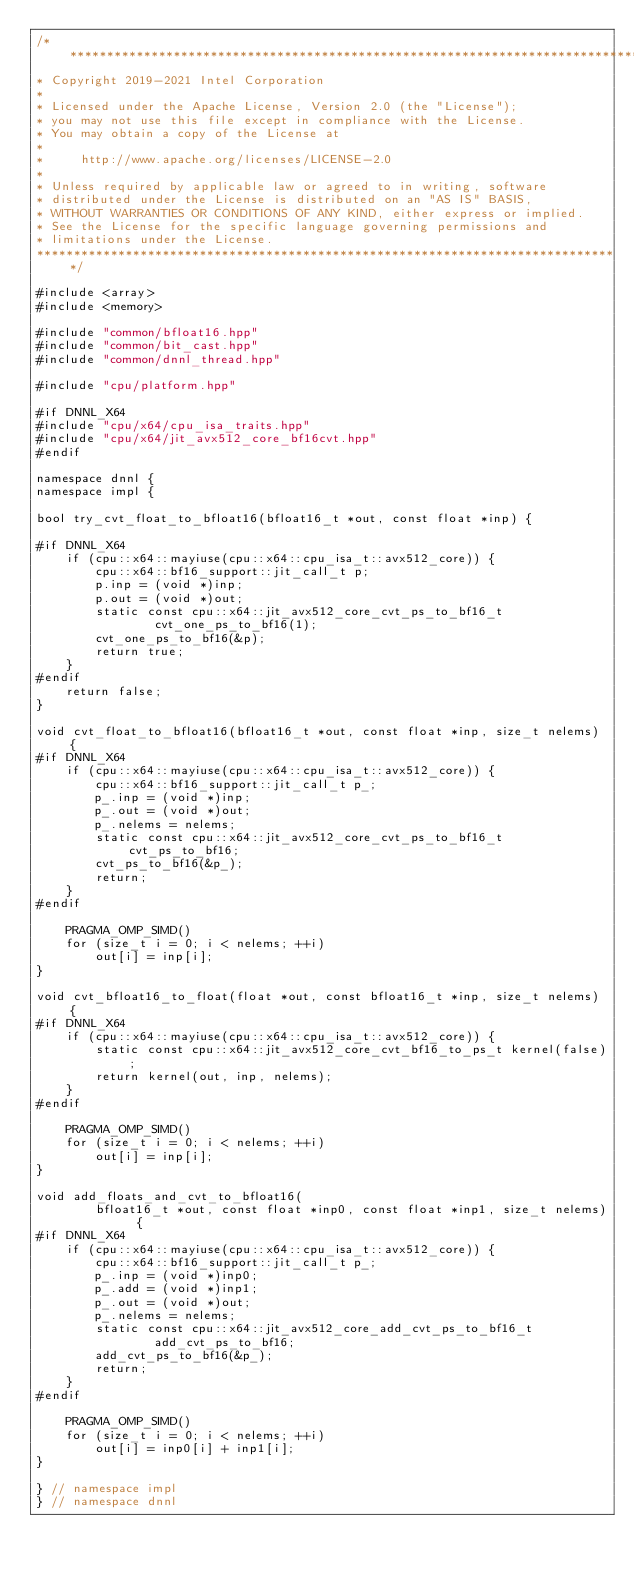<code> <loc_0><loc_0><loc_500><loc_500><_C++_>/*******************************************************************************
* Copyright 2019-2021 Intel Corporation
*
* Licensed under the Apache License, Version 2.0 (the "License");
* you may not use this file except in compliance with the License.
* You may obtain a copy of the License at
*
*     http://www.apache.org/licenses/LICENSE-2.0
*
* Unless required by applicable law or agreed to in writing, software
* distributed under the License is distributed on an "AS IS" BASIS,
* WITHOUT WARRANTIES OR CONDITIONS OF ANY KIND, either express or implied.
* See the License for the specific language governing permissions and
* limitations under the License.
*******************************************************************************/

#include <array>
#include <memory>

#include "common/bfloat16.hpp"
#include "common/bit_cast.hpp"
#include "common/dnnl_thread.hpp"

#include "cpu/platform.hpp"

#if DNNL_X64
#include "cpu/x64/cpu_isa_traits.hpp"
#include "cpu/x64/jit_avx512_core_bf16cvt.hpp"
#endif

namespace dnnl {
namespace impl {

bool try_cvt_float_to_bfloat16(bfloat16_t *out, const float *inp) {

#if DNNL_X64
    if (cpu::x64::mayiuse(cpu::x64::cpu_isa_t::avx512_core)) {
        cpu::x64::bf16_support::jit_call_t p;
        p.inp = (void *)inp;
        p.out = (void *)out;
        static const cpu::x64::jit_avx512_core_cvt_ps_to_bf16_t
                cvt_one_ps_to_bf16(1);
        cvt_one_ps_to_bf16(&p);
        return true;
    }
#endif
    return false;
}

void cvt_float_to_bfloat16(bfloat16_t *out, const float *inp, size_t nelems) {
#if DNNL_X64
    if (cpu::x64::mayiuse(cpu::x64::cpu_isa_t::avx512_core)) {
        cpu::x64::bf16_support::jit_call_t p_;
        p_.inp = (void *)inp;
        p_.out = (void *)out;
        p_.nelems = nelems;
        static const cpu::x64::jit_avx512_core_cvt_ps_to_bf16_t cvt_ps_to_bf16;
        cvt_ps_to_bf16(&p_);
        return;
    }
#endif

    PRAGMA_OMP_SIMD()
    for (size_t i = 0; i < nelems; ++i)
        out[i] = inp[i];
}

void cvt_bfloat16_to_float(float *out, const bfloat16_t *inp, size_t nelems) {
#if DNNL_X64
    if (cpu::x64::mayiuse(cpu::x64::cpu_isa_t::avx512_core)) {
        static const cpu::x64::jit_avx512_core_cvt_bf16_to_ps_t kernel(false);
        return kernel(out, inp, nelems);
    }
#endif

    PRAGMA_OMP_SIMD()
    for (size_t i = 0; i < nelems; ++i)
        out[i] = inp[i];
}

void add_floats_and_cvt_to_bfloat16(
        bfloat16_t *out, const float *inp0, const float *inp1, size_t nelems) {
#if DNNL_X64
    if (cpu::x64::mayiuse(cpu::x64::cpu_isa_t::avx512_core)) {
        cpu::x64::bf16_support::jit_call_t p_;
        p_.inp = (void *)inp0;
        p_.add = (void *)inp1;
        p_.out = (void *)out;
        p_.nelems = nelems;
        static const cpu::x64::jit_avx512_core_add_cvt_ps_to_bf16_t
                add_cvt_ps_to_bf16;
        add_cvt_ps_to_bf16(&p_);
        return;
    }
#endif

    PRAGMA_OMP_SIMD()
    for (size_t i = 0; i < nelems; ++i)
        out[i] = inp0[i] + inp1[i];
}

} // namespace impl
} // namespace dnnl
</code> 